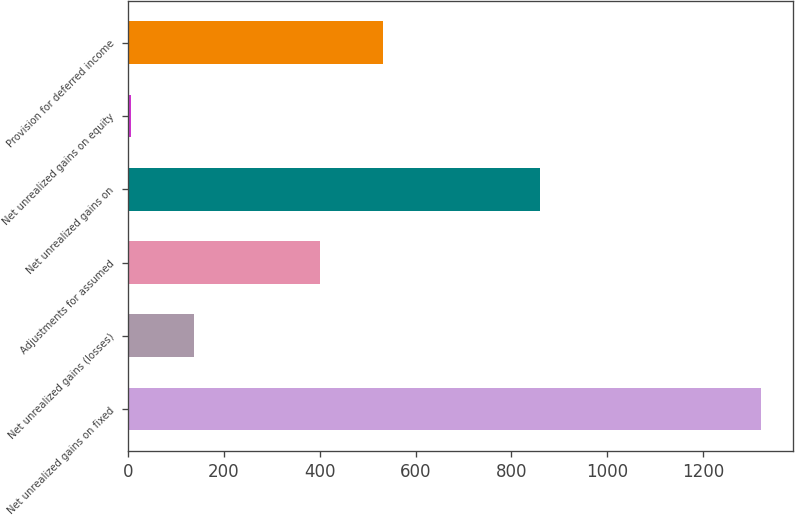Convert chart. <chart><loc_0><loc_0><loc_500><loc_500><bar_chart><fcel>Net unrealized gains on fixed<fcel>Net unrealized gains (losses)<fcel>Adjustments for assumed<fcel>Net unrealized gains on<fcel>Net unrealized gains on equity<fcel>Provision for deferred income<nl><fcel>1321.1<fcel>138.23<fcel>401.09<fcel>859<fcel>6.8<fcel>532.52<nl></chart> 